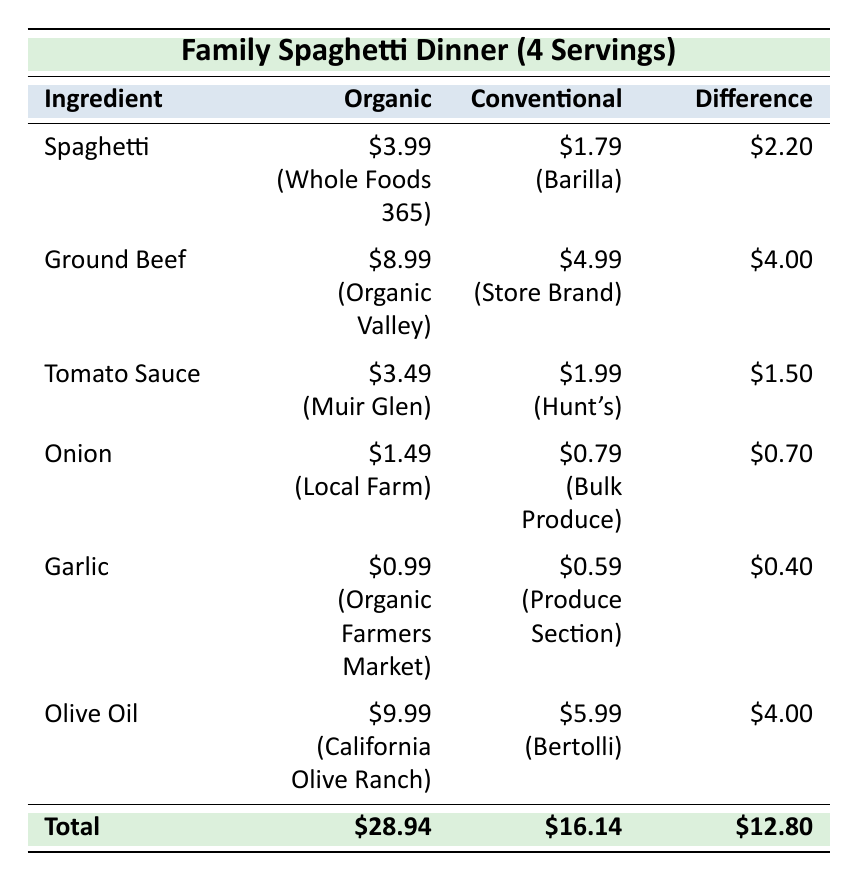What is the price difference for spaghetti between organic and conventional? The price for organic spaghetti is $3.99, and the price for conventional spaghetti is $1.79. To find the difference, we subtract the conventional price from the organic price: $3.99 - $1.79 = $2.20.
Answer: $2.20 Which ingredient has the highest price in the organic category? Looking at the organic prices, the highest price is for olive oil, which is $9.99.
Answer: Olive oil What is the total cost of conventional ingredients for this meal? To find the total cost of conventional ingredients, we sum the prices: $1.79 (spaghetti) + $4.99 (ground beef) + $1.99 (tomato sauce) + $0.79 (onion) + $0.59 (garlic) + $5.99 (olive oil) = $16.14.
Answer: $16.14 Is organic garlic more expensive than conventional garlic? Organic garlic costs $0.99, while conventional garlic costs $0.59. Since $0.99 is greater than $0.59, the statement is true.
Answer: Yes What are the total savings if a family chooses conventional ingredients over organic? The total cost of organic ingredients is $28.94 and the total cost of conventional ingredients is $16.14. The savings can be calculated by subtracting the conventional total from the organic total: $28.94 - $16.14 = $12.80.
Answer: $12.80 Which ingredient has the largest price difference between organic and conventional? The price differences for each ingredient are: $2.20 (spaghetti), $4.00 (ground beef), $1.50 (tomato sauce), $0.70 (onion), $0.40 (garlic), and $4.00 (olive oil). The largest difference is for ground beef and olive oil, both at $4.00.
Answer: Ground beef and olive oil What is the combined price of organic and conventional tomato sauce? The price of organic tomato sauce is $3.49 and conventional tomato sauce is $1.99. The combined price is $3.49 + $1.99 = $5.48.
Answer: $5.48 Are all organic ingredients priced higher than conventional ingredients? By comparing the prices: organic spaghetti ($3.99) is more than conventional ($1.79), organic ground beef ($8.99) is more than conventional ($4.99), organic tomato sauce ($3.49) is more than conventional ($1.99), but organic onion ($1.49) is more than conventional ($0.79), organic garlic ($0.99) is more than conventional ($0.59), and organic olive oil ($9.99) is more than conventional ($5.99). Thus, all the organic prices are higher.
Answer: Yes Which organic ingredient is the least expensive? The prices for organic ingredients are: spaghetti ($3.99), ground beef ($8.99), tomato sauce ($3.49), onion ($1.49), garlic ($0.99), and olive oil ($9.99). The least expensive is organic garlic at $0.99.
Answer: Garlic 